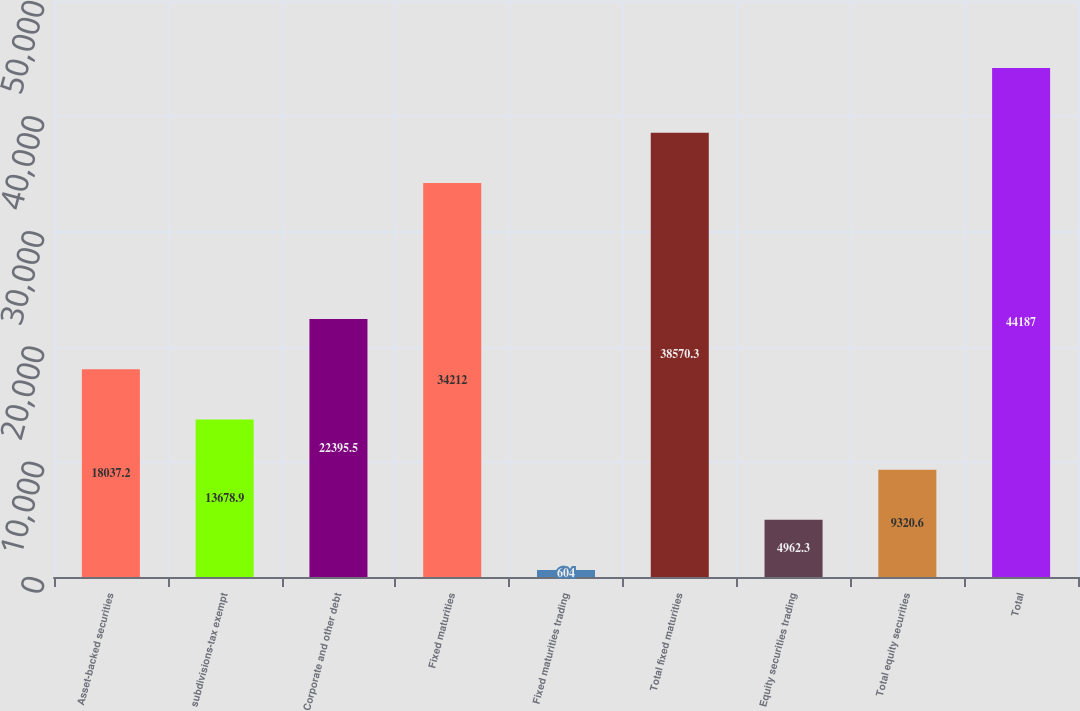<chart> <loc_0><loc_0><loc_500><loc_500><bar_chart><fcel>Asset-backed securities<fcel>subdivisions-tax exempt<fcel>Corporate and other debt<fcel>Fixed maturities<fcel>Fixed maturities trading<fcel>Total fixed maturities<fcel>Equity securities trading<fcel>Total equity securities<fcel>Total<nl><fcel>18037.2<fcel>13678.9<fcel>22395.5<fcel>34212<fcel>604<fcel>38570.3<fcel>4962.3<fcel>9320.6<fcel>44187<nl></chart> 